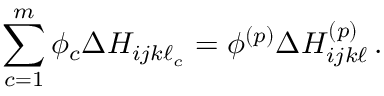Convert formula to latex. <formula><loc_0><loc_0><loc_500><loc_500>\sum _ { c = 1 } ^ { m } \phi _ { c } \Delta H _ { i j k \ell _ { c } } = \phi ^ { ( p ) } \Delta H _ { i j k \ell } ^ { ( p ) } \, .</formula> 